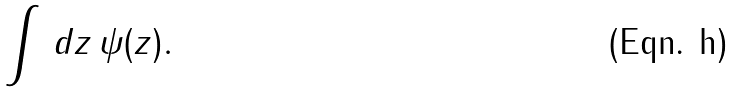<formula> <loc_0><loc_0><loc_500><loc_500>\int \, d z \, \psi ( z ) .</formula> 